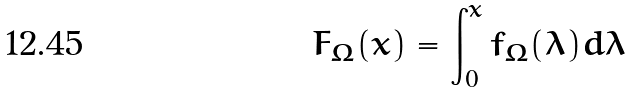Convert formula to latex. <formula><loc_0><loc_0><loc_500><loc_500>F _ { \Omega } ( x ) = \int _ { 0 } ^ { x } f _ { \Omega } ( \lambda ) d \lambda</formula> 